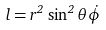Convert formula to latex. <formula><loc_0><loc_0><loc_500><loc_500>l = r ^ { 2 } \, \sin ^ { 2 } \theta \dot { \phi }</formula> 